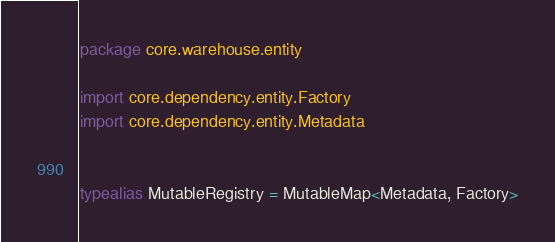Convert code to text. <code><loc_0><loc_0><loc_500><loc_500><_Kotlin_>package core.warehouse.entity

import core.dependency.entity.Factory
import core.dependency.entity.Metadata


typealias MutableRegistry = MutableMap<Metadata, Factory>
</code> 